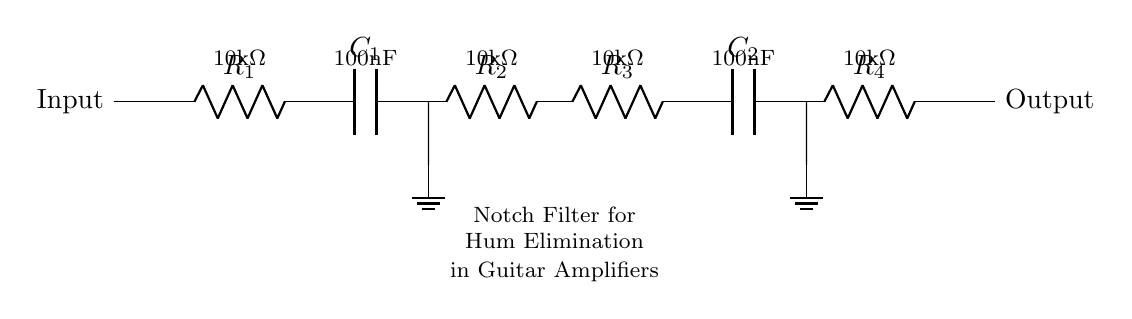What type of filter is depicted in this circuit? The circuit diagram shows a notch filter used specifically to eliminate hum frequencies, which is common in audio applications like guitar amplifiers. The term "Notch Filter" is explicitly labeled in the diagram.
Answer: Notch filter What is the value of R1? R1 is labeled in the circuit as having a resistance value of 10 kilo-ohms. This value is indicated next to the resistor symbol in the diagram.
Answer: 10k ohm How many capacitors are present in this circuit? By examining the circuit diagram, there are two capacitors indicated by the C symbols. Both are necessary for the operation of the notch filter at different stages.
Answer: Two What is the purpose of this notch filter in guitar amplifiers? The primary function of the notch filter in this context is to reduce or eliminate unwanted hum frequencies, like the 60 Hz mains hum, allowing the guitar signal to be clearer. This is derived from the general understanding of notch filters in audio circuits.
Answer: Eliminate hum What happens if R3 is replaced with a lower value resistor? Lowering the value of R3 would change the filter's bandwidth and potentially affect the notch's depth, resulting in a less effective hum reduction. It alters the impedance seen by the capacitors, shifting the frequency response of the circuit.
Answer: Decreased effectiveness At what frequency will this notch filter ideally attenuate the signal? The notch filter's frequency is determined by the values of R and C in the circuit. Given the component values, the frequency is typically designed to target the specific hum frequency, commonly around 60 Hz in electric appliances.
Answer: Approximately 60 Hz 